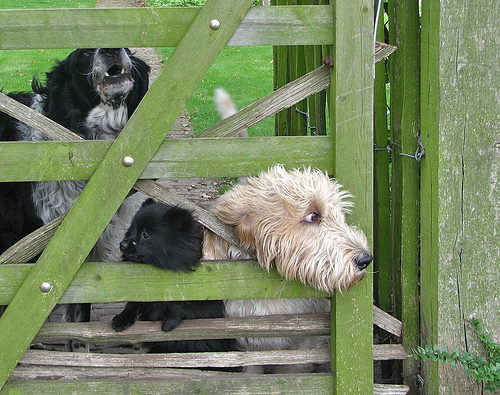<image>
Is the dog in front of the gate? No. The dog is not in front of the gate. The spatial positioning shows a different relationship between these objects. 